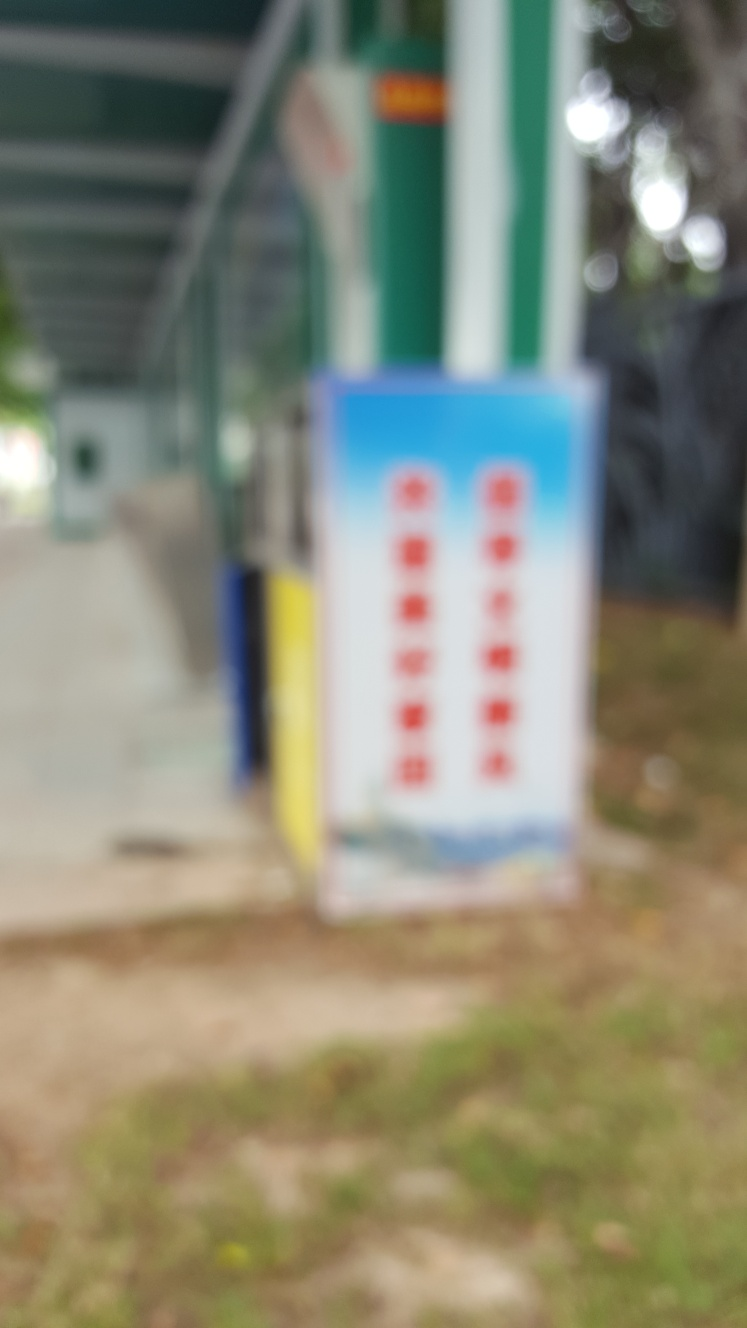What might be the reason for the blurriness in this image? The blurriness could stem from a number of reasons, such as the camera's focus not being set correctly, a quick movement at the moment the photo was taken, or it could be a deliberate artistic technique to convey motion or introduce an element of abstraction. 